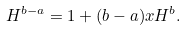<formula> <loc_0><loc_0><loc_500><loc_500>H ^ { b - a } = 1 + ( b - a ) x H ^ { b } .</formula> 